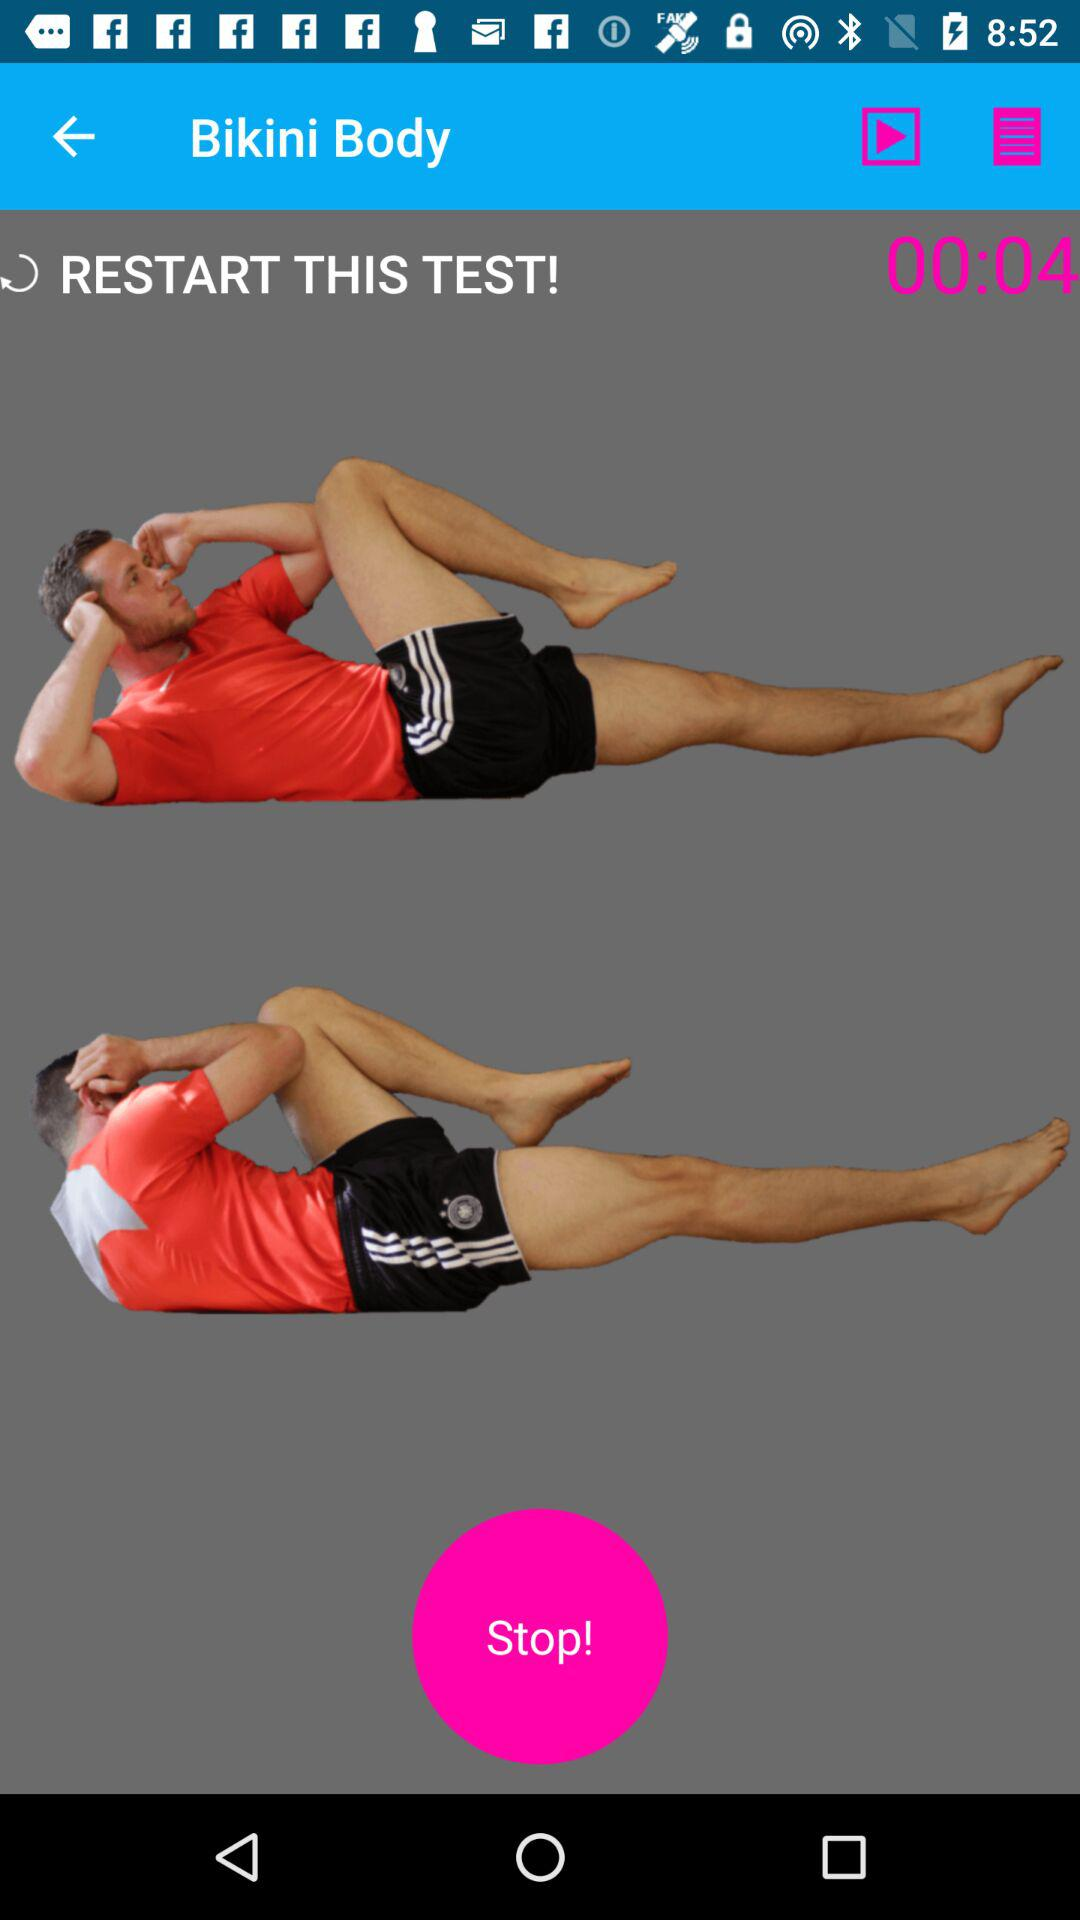What's the name of the exercise?
When the provided information is insufficient, respond with <no answer>. <no answer> 